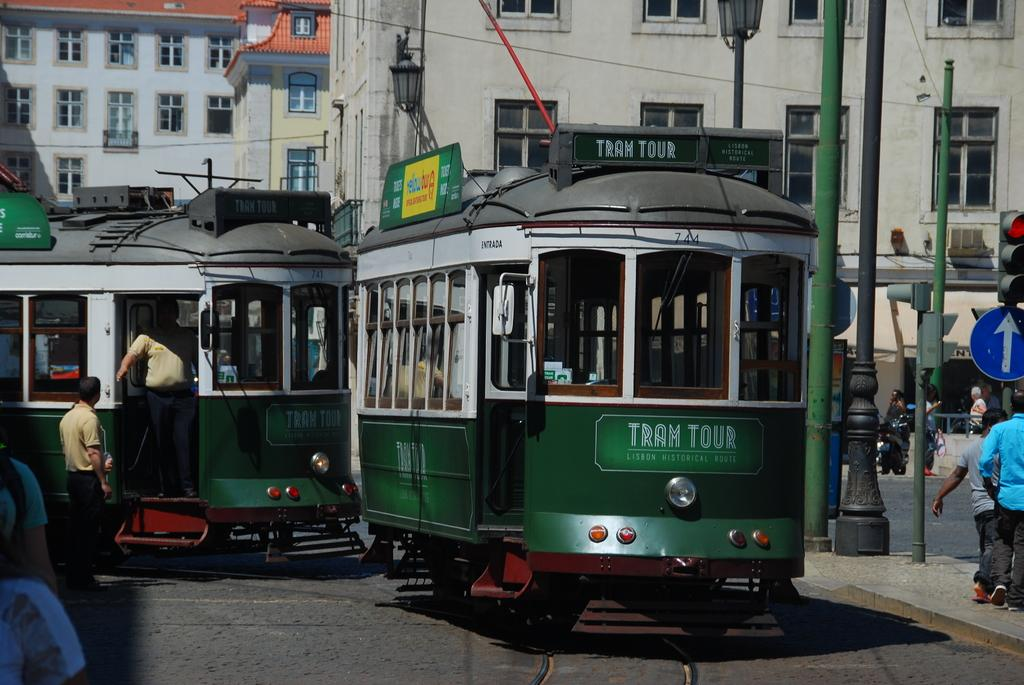What is the main subject of the image? The main subject of the image is a train. Can you describe the people in the image? There is a group of people in the image. What safety feature is present in the image? Signal lights are present in the image. What type of information might be conveyed by the signboard in the image? The signboard attached to a pole in the image might convey information about the train or the area. What can be seen in the background of the image? There are buildings in the background of the image. What type of oatmeal is being served to the passengers in the image? There is no oatmeal present in the image; it features a train and related elements. 